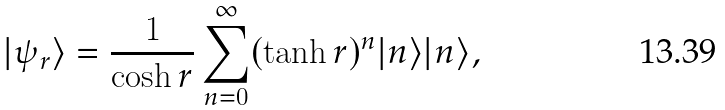Convert formula to latex. <formula><loc_0><loc_0><loc_500><loc_500>| \psi _ { r } \rangle = \frac { 1 } { \cosh r } \sum _ { n = 0 } ^ { \infty } ( \tanh r ) ^ { n } | n \rangle | n \rangle ,</formula> 